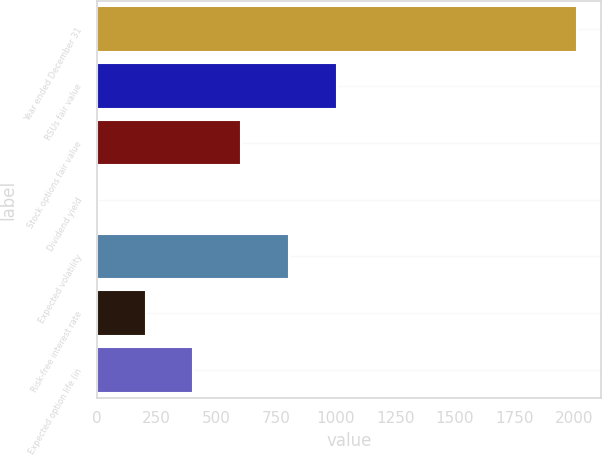Convert chart to OTSL. <chart><loc_0><loc_0><loc_500><loc_500><bar_chart><fcel>Year ended December 31<fcel>RSUs fair value<fcel>Stock options fair value<fcel>Dividend yield<fcel>Expected volatility<fcel>Risk-free interest rate<fcel>Expected option life (in<nl><fcel>2014<fcel>1007.9<fcel>605.46<fcel>1.8<fcel>806.68<fcel>203.02<fcel>404.24<nl></chart> 